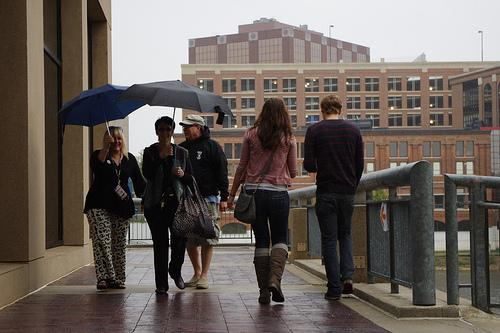Comment on the fashion choices of the individuals in the image. Various styles are showcased, including tall brown boots, animal print pants, a grey cap, and blue jeans, as people walk in the rain. Describe key details about the people in the image, including their clothing. There's a blonde woman in animal print pants, a woman with long dark hair and knee-high boots, a man in a grey cap, and some individuals wearing blue jeans, all walking in the rain. Describe the actions of the individuals in the image. People are walking on a harbor sidewalk, holding umbrellas and wearing various types of clothing while facing inclement weather. Mention the main event happening in the image and the location. Five people are walking in the rain on a harbor sidewalk, some holding umbrellas. Describe the weather conditions and how they are affecting the people in the image. It is raining, and the people walking on the harbor sidewalk are holding umbrellas and wearing various clothes to protect themselves from the rain. Based on the image details, describe the overall mood of the scene. The scene has a moody atmosphere as a group of five people walk through the rain on a harbor sidewalk. Highlight the prominent features of the image, including objects and clothing. The image features people walking on a harbor sidewalk, holding umbrellas, with notable clothing such as brown boots, animal print pants, and a grey cap. List the types of clothing and accessories seen in the image. Tall brown boots, long-sleeved striped shirt, animal print pants, blue umbrella, grey cap, short hair and glasses, modern metal railing, and black umbrella. State the main activity and the environment where it is taking place. A group of five people is strolling in the rain along a sidewalk by the harbor. 